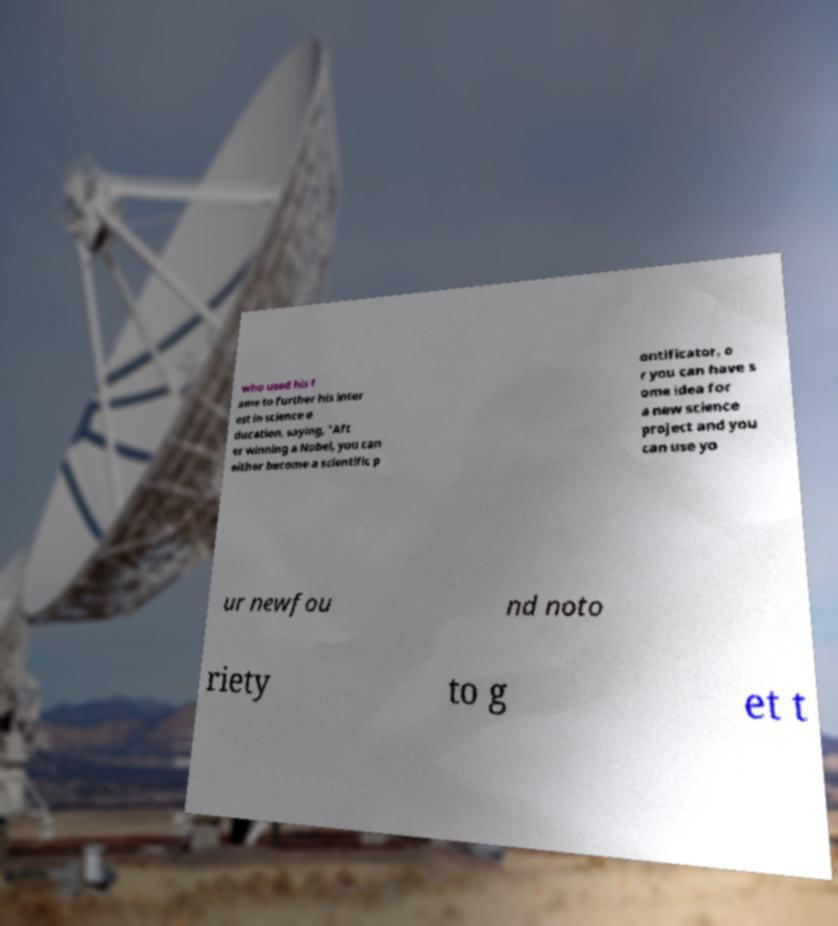Can you read and provide the text displayed in the image?This photo seems to have some interesting text. Can you extract and type it out for me? who used his f ame to further his inter est in science e ducation, saying, "Aft er winning a Nobel, you can either become a scientific p ontificator, o r you can have s ome idea for a new science project and you can use yo ur newfou nd noto riety to g et t 